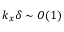<formula> <loc_0><loc_0><loc_500><loc_500>k _ { x } \delta \sim O ( 1 )</formula> 